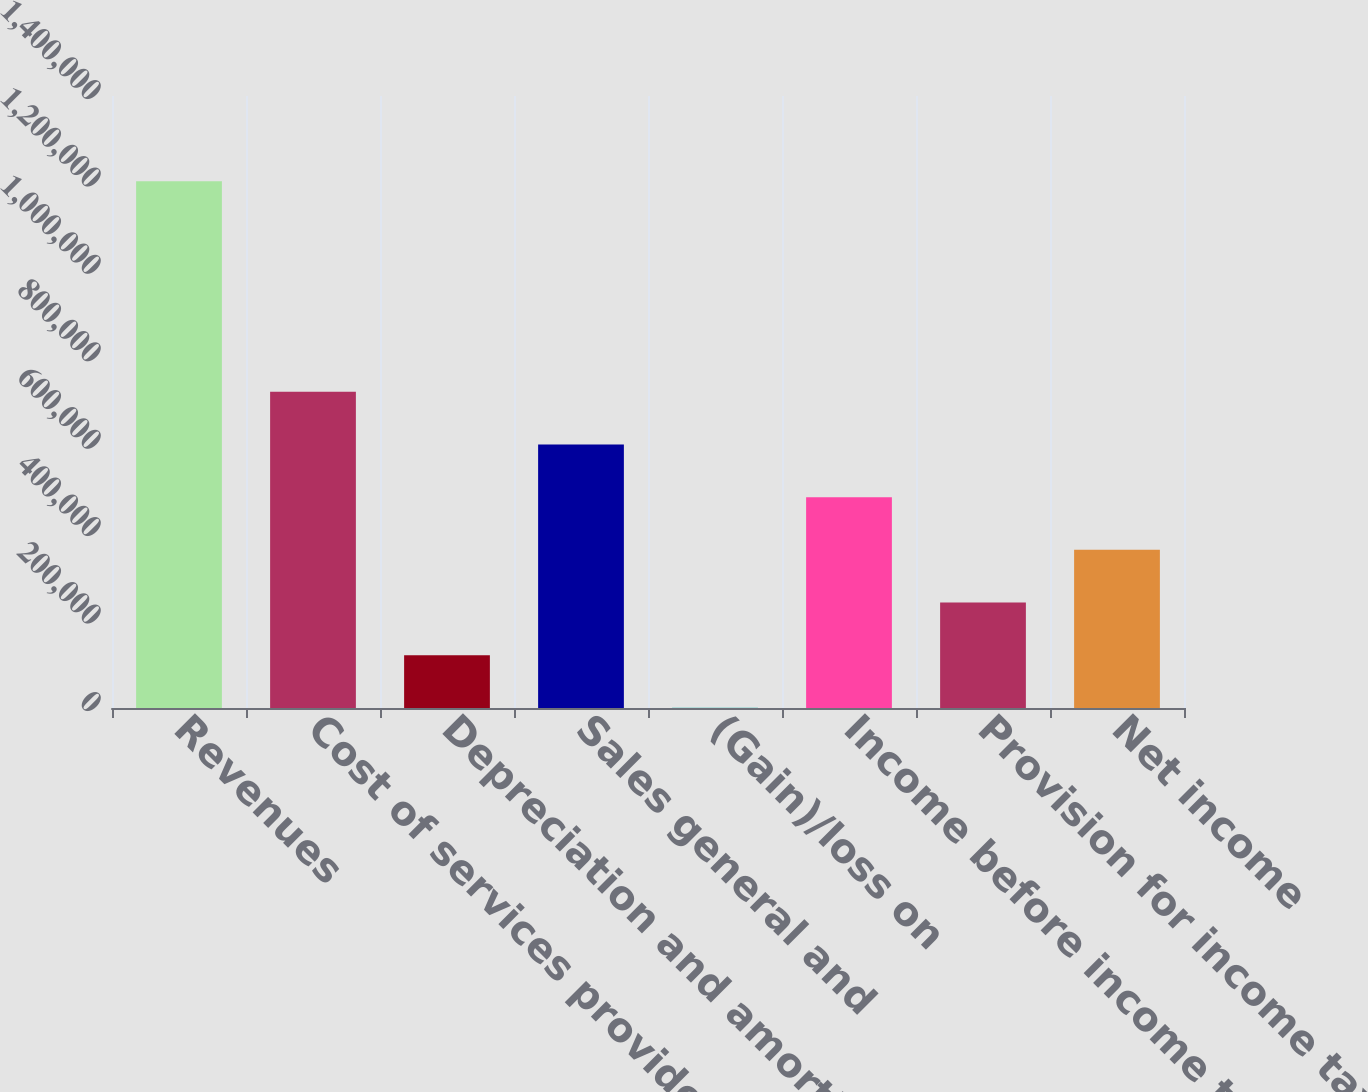<chart> <loc_0><loc_0><loc_500><loc_500><bar_chart><fcel>Revenues<fcel>Cost of services provided<fcel>Depreciation and amortization<fcel>Sales general and<fcel>(Gain)/loss on<fcel>Income before income taxes<fcel>Provision for income taxes<fcel>Net income<nl><fcel>1.20506e+06<fcel>723200<fcel>120871<fcel>602734<fcel>405<fcel>482269<fcel>241337<fcel>361803<nl></chart> 